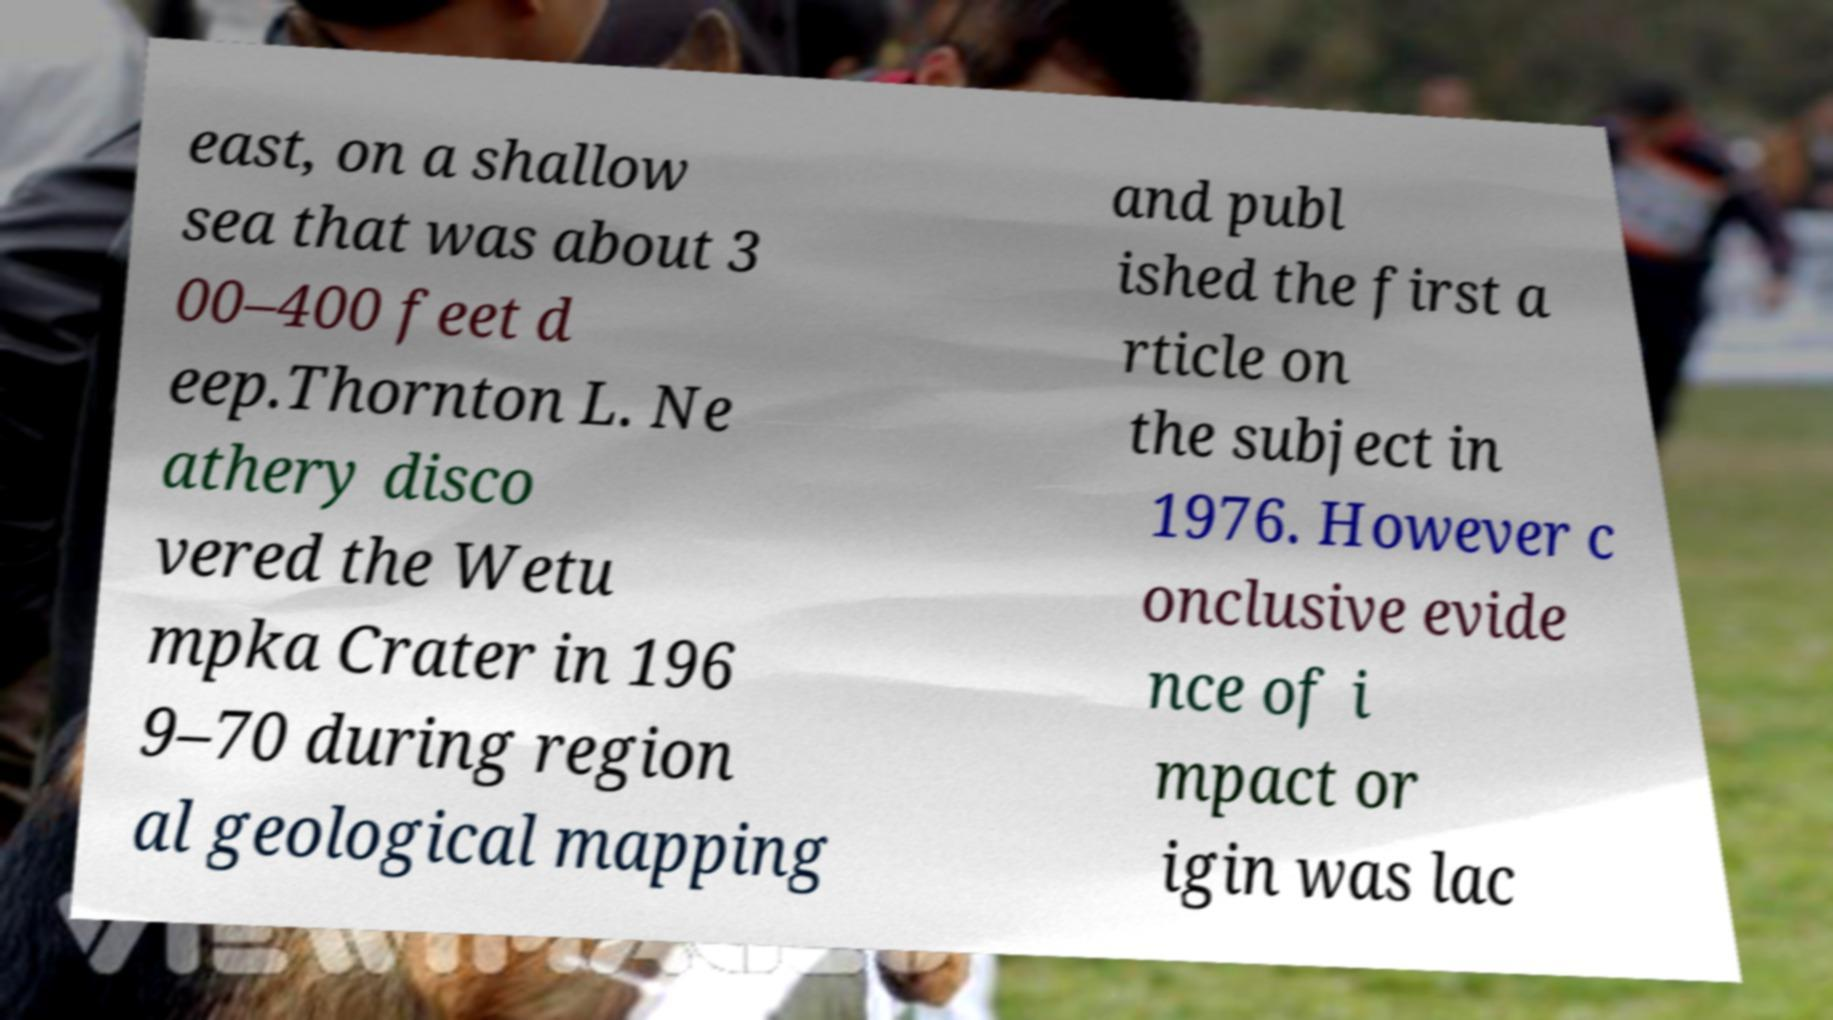What messages or text are displayed in this image? I need them in a readable, typed format. east, on a shallow sea that was about 3 00–400 feet d eep.Thornton L. Ne athery disco vered the Wetu mpka Crater in 196 9–70 during region al geological mapping and publ ished the first a rticle on the subject in 1976. However c onclusive evide nce of i mpact or igin was lac 